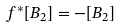Convert formula to latex. <formula><loc_0><loc_0><loc_500><loc_500>f ^ { * } [ B _ { 2 } ] = - [ B _ { 2 } ]</formula> 